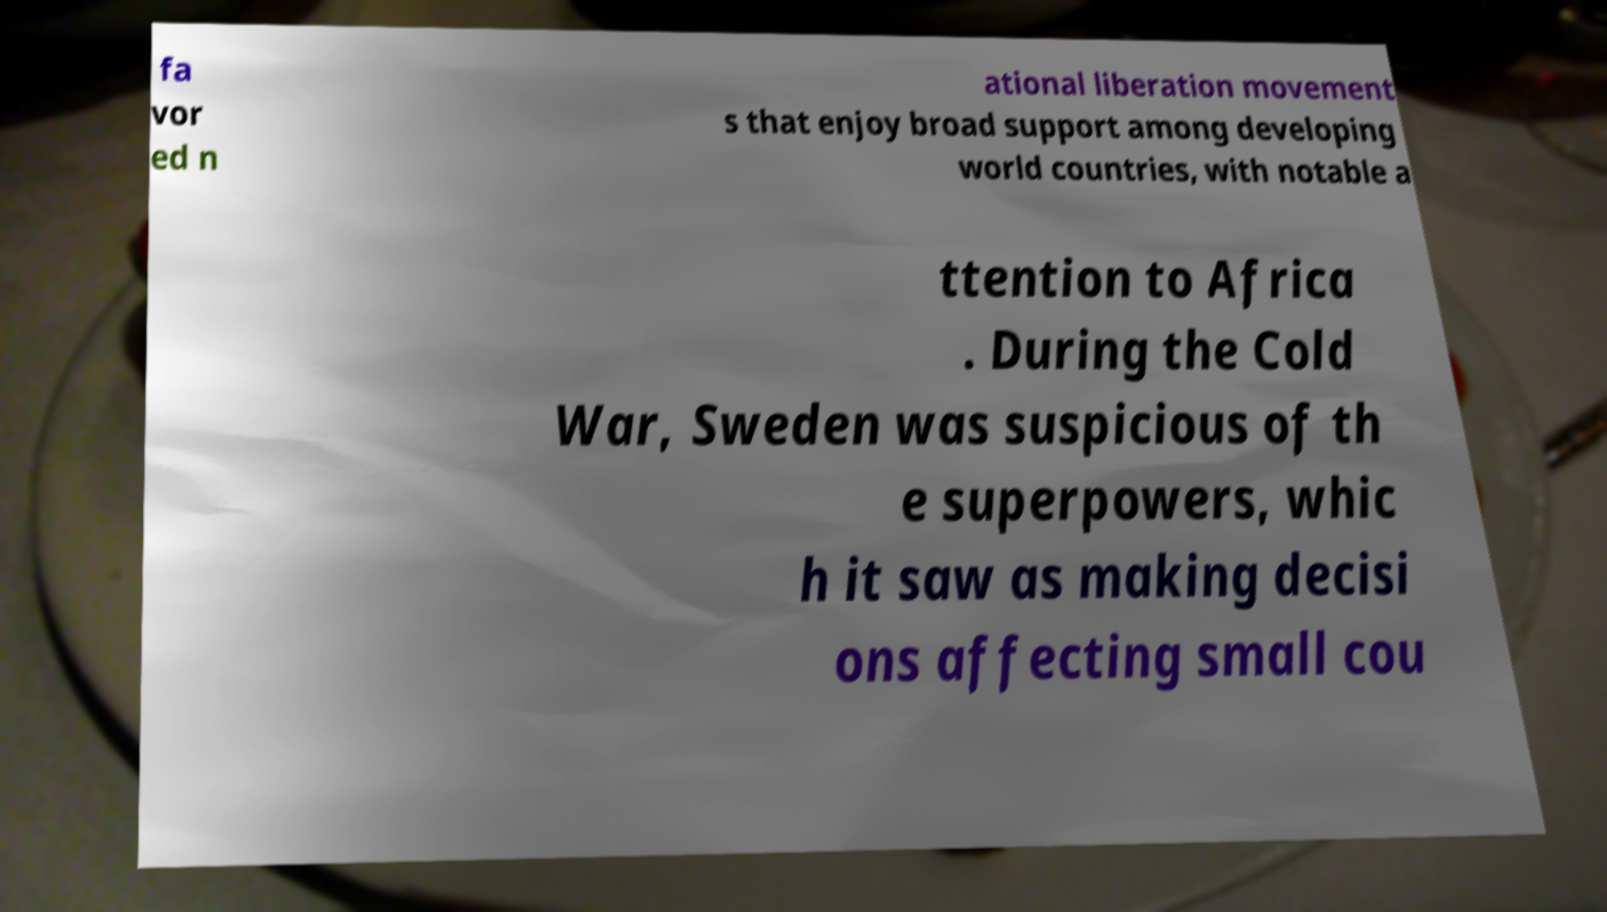Please read and relay the text visible in this image. What does it say? fa vor ed n ational liberation movement s that enjoy broad support among developing world countries, with notable a ttention to Africa . During the Cold War, Sweden was suspicious of th e superpowers, whic h it saw as making decisi ons affecting small cou 